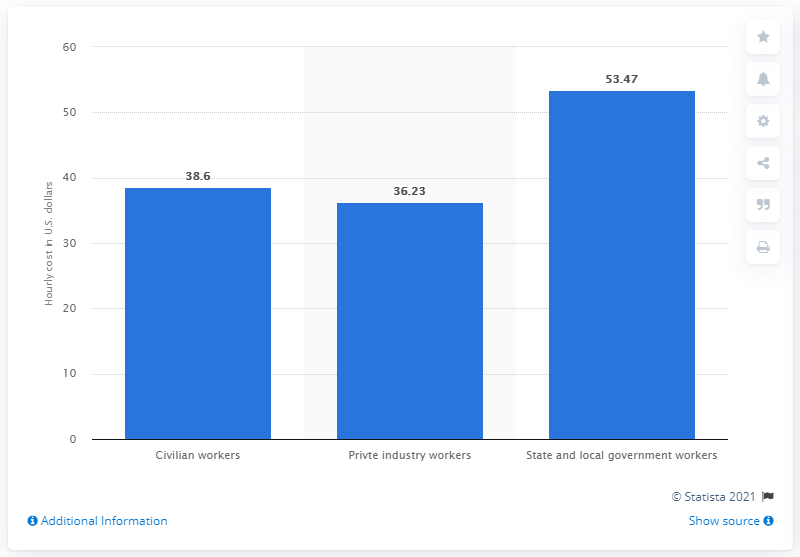Highlight a few significant elements in this photo. The average total compensation cost per hour for state and local government workers was $53.47. 